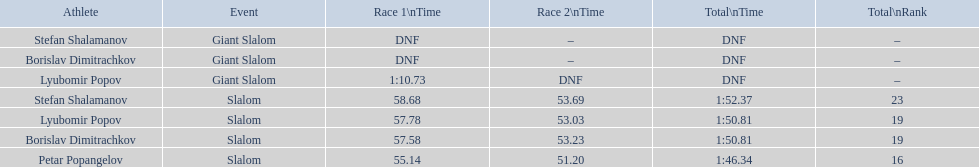What is the difference in time for petar popangelov in race 1and 2 3.94. 